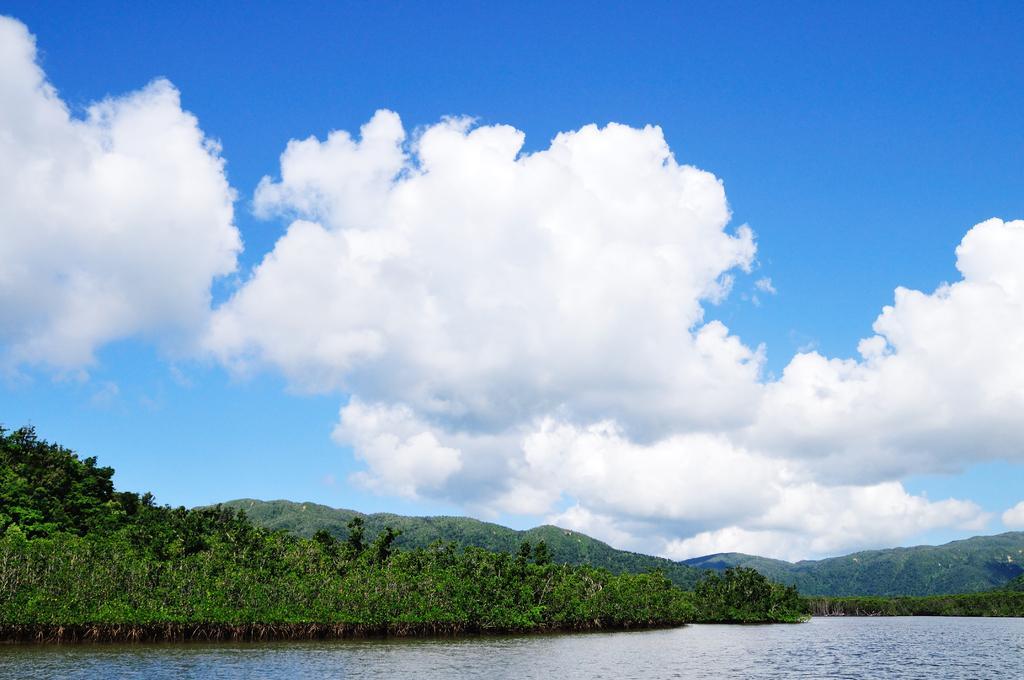In one or two sentences, can you explain what this image depicts? This picture is clicked outside. In the foreground we can see a water body and the plants. In the background we can see the sky which is full of clouds and we can see the hills. 